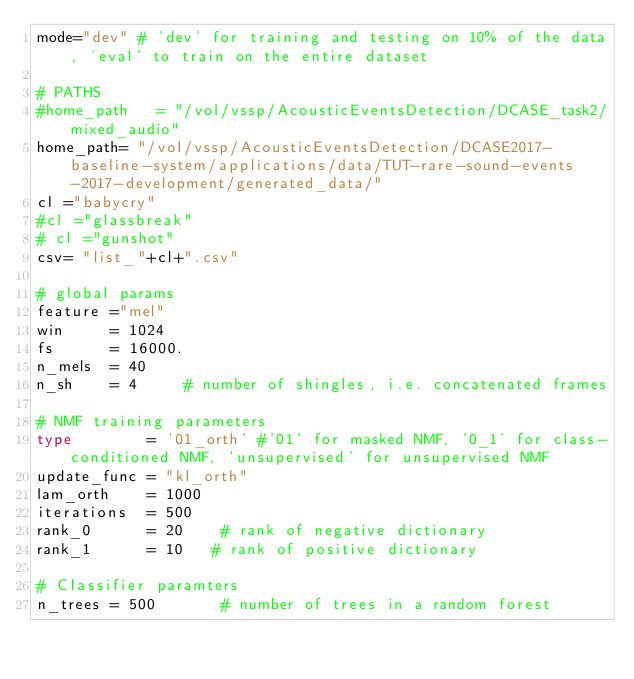Convert code to text. <code><loc_0><loc_0><loc_500><loc_500><_Python_>mode="dev" # 'dev' for training and testing on 10% of the data, 'eval' to train on the entire dataset

# PATHS
#home_path   = "/vol/vssp/AcousticEventsDetection/DCASE_task2/mixed_audio"
home_path= "/vol/vssp/AcousticEventsDetection/DCASE2017-baseline-system/applications/data/TUT-rare-sound-events-2017-development/generated_data/"
cl ="babycry"
#cl ="glassbreak"  
# cl ="gunshot"                     
csv= "list_"+cl+".csv"

# global params
feature ="mel"
win     = 1024
fs      = 16000.
n_mels  = 40
n_sh    = 4     # number of shingles, i.e. concatenated frames

# NMF training parameters
type        = '01_orth' #'01' for masked NMF, '0_1' for class-conditioned NMF, 'unsupervised' for unsupervised NMF
update_func = "kl_orth"
lam_orth    = 1000
iterations  = 500
rank_0      = 20    # rank of negative dictionary
rank_1      = 10   # rank of positive dictionary

# Classifier paramters
n_trees = 500       # number of trees in a random forest
</code> 